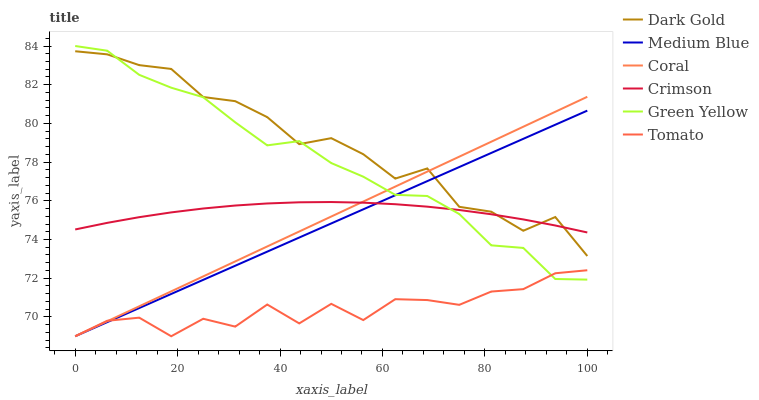Does Tomato have the minimum area under the curve?
Answer yes or no. Yes. Does Dark Gold have the maximum area under the curve?
Answer yes or no. Yes. Does Coral have the minimum area under the curve?
Answer yes or no. No. Does Coral have the maximum area under the curve?
Answer yes or no. No. Is Coral the smoothest?
Answer yes or no. Yes. Is Dark Gold the roughest?
Answer yes or no. Yes. Is Dark Gold the smoothest?
Answer yes or no. No. Is Coral the roughest?
Answer yes or no. No. Does Tomato have the lowest value?
Answer yes or no. Yes. Does Dark Gold have the lowest value?
Answer yes or no. No. Does Green Yellow have the highest value?
Answer yes or no. Yes. Does Dark Gold have the highest value?
Answer yes or no. No. Is Tomato less than Dark Gold?
Answer yes or no. Yes. Is Crimson greater than Tomato?
Answer yes or no. Yes. Does Medium Blue intersect Coral?
Answer yes or no. Yes. Is Medium Blue less than Coral?
Answer yes or no. No. Is Medium Blue greater than Coral?
Answer yes or no. No. Does Tomato intersect Dark Gold?
Answer yes or no. No. 